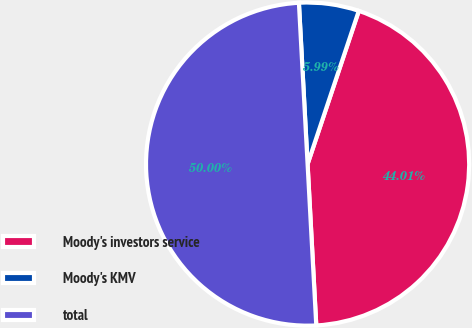<chart> <loc_0><loc_0><loc_500><loc_500><pie_chart><fcel>Moody's investors service<fcel>Moody's KMV<fcel>total<nl><fcel>44.01%<fcel>5.99%<fcel>50.0%<nl></chart> 